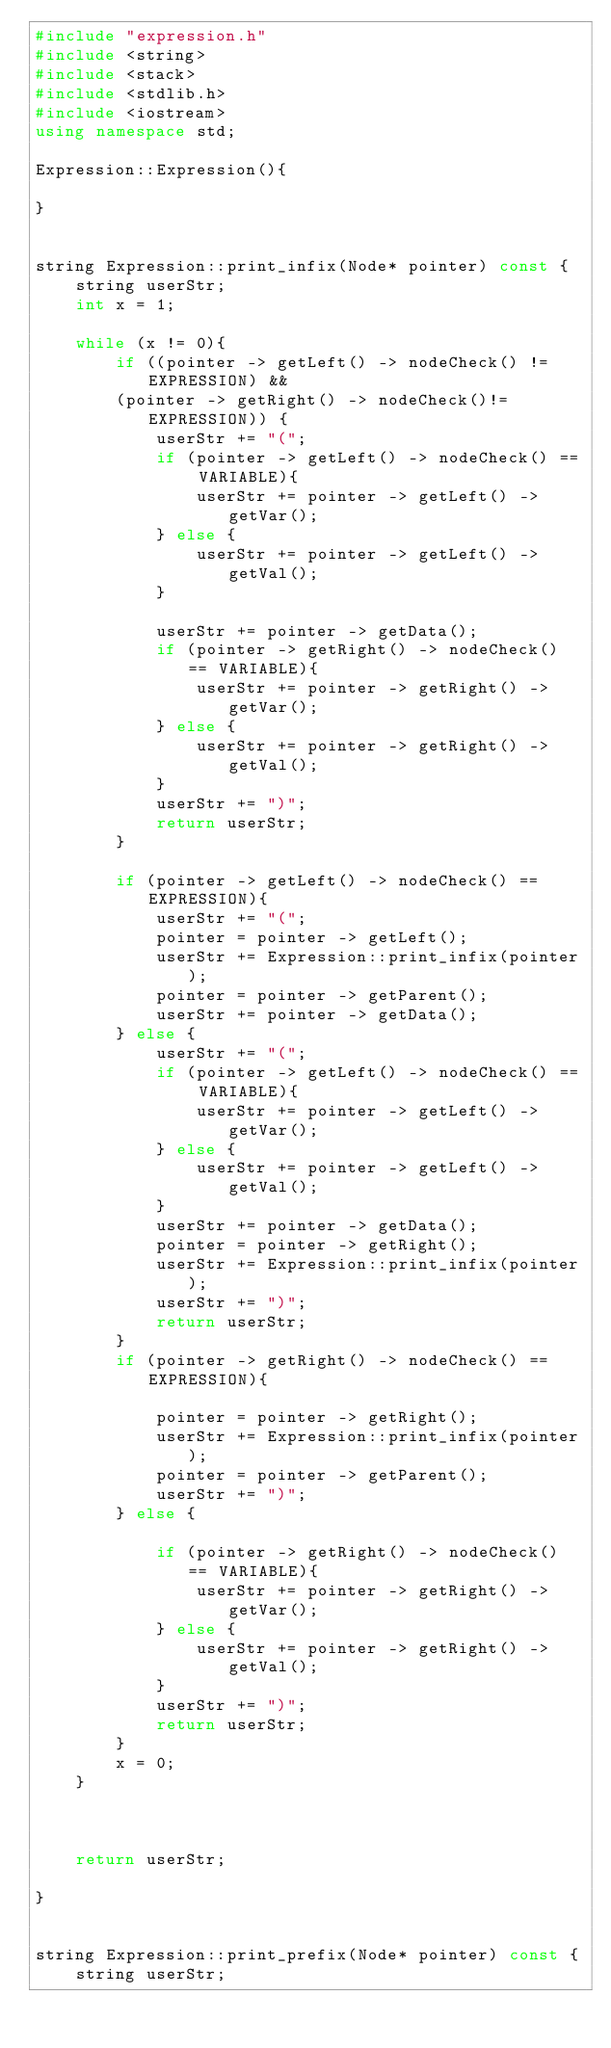<code> <loc_0><loc_0><loc_500><loc_500><_C++_>#include "expression.h"
#include <string>
#include <stack>
#include <stdlib.h>
#include <iostream>
using namespace std;

Expression::Expression(){
	
}


string Expression::print_infix(Node* pointer) const {
	string userStr;
	int x = 1;
	
	while (x != 0){
		if ((pointer -> getLeft() -> nodeCheck() != EXPRESSION) && 
		(pointer -> getRight() -> nodeCheck()!= EXPRESSION)) {
			userStr += "(";
			if (pointer -> getLeft() -> nodeCheck() == VARIABLE){
				userStr += pointer -> getLeft() -> getVar();
			} else {
				userStr += pointer -> getLeft() -> getVal();
			}

			userStr += pointer -> getData();
			if (pointer -> getRight() -> nodeCheck() == VARIABLE){
				userStr += pointer -> getRight() -> getVar();
			} else {
				userStr += pointer -> getRight() -> getVal();
			}
			userStr += ")";
			return userStr;
		}
			
		if (pointer -> getLeft() -> nodeCheck() == EXPRESSION){
			userStr += "(";
			pointer = pointer -> getLeft();
			userStr += Expression::print_infix(pointer);
			pointer = pointer -> getParent();
			userStr += pointer -> getData();
		} else {
			userStr += "(";
			if (pointer -> getLeft() -> nodeCheck() == VARIABLE){
				userStr += pointer -> getLeft() -> getVar();
			} else {
				userStr += pointer -> getLeft() -> getVal();
			}
			userStr += pointer -> getData();
			pointer = pointer -> getRight();
			userStr += Expression::print_infix(pointer);
			userStr += ")";
			return userStr;
		}
		if (pointer -> getRight() -> nodeCheck() == EXPRESSION){
			
			pointer = pointer -> getRight();
			userStr += Expression::print_infix(pointer);
			pointer = pointer -> getParent();
			userStr += ")";
		} else {
			
			if (pointer -> getRight() -> nodeCheck() == VARIABLE){
				userStr += pointer -> getRight() -> getVar();
			} else {
				userStr += pointer -> getRight() -> getVal();
			}
			userStr += ")";
			return userStr;
		}
		x = 0;
	}


	
	return userStr;

}


string Expression::print_prefix(Node* pointer) const {
	string userStr;</code> 